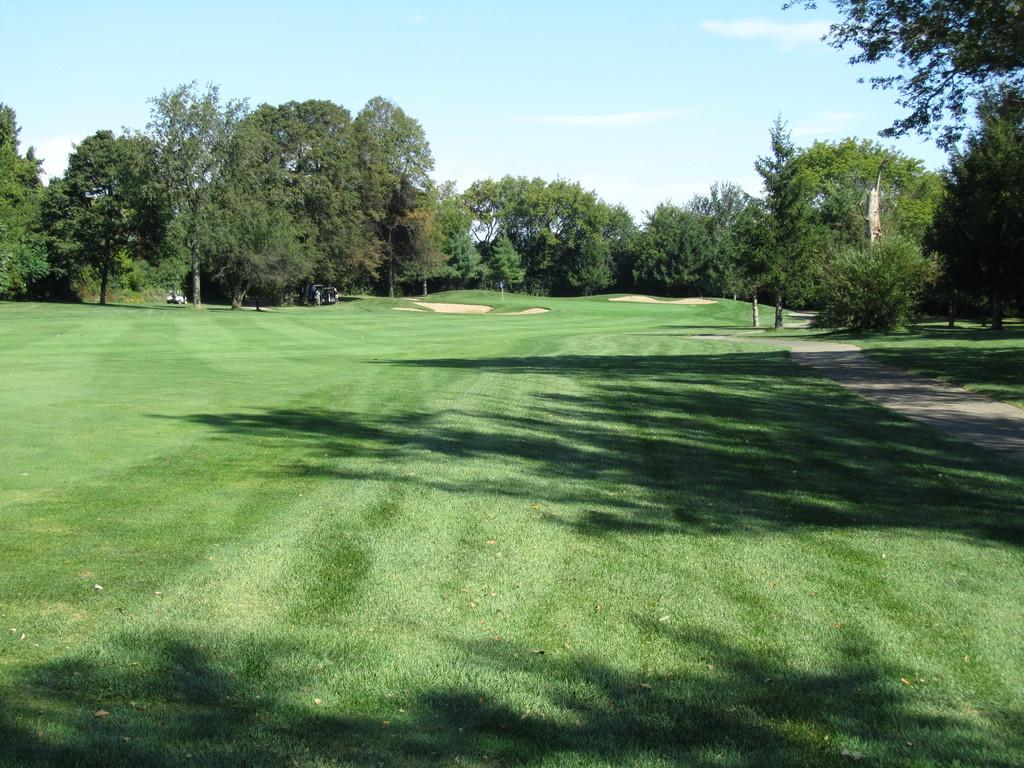What type of vegetation is present in the image? There are trees in the image. What is covering the ground in the image? There is grass on the ground in the image. How would you describe the sky in the image? The sky is blue and cloudy in the image. What type of cord is hanging from the trees in the image? There is no cord present in the image; it only features trees, grass, and a blue, cloudy sky. What type of meal is being prepared in the image? There is no meal preparation or any indication of food in the image. 